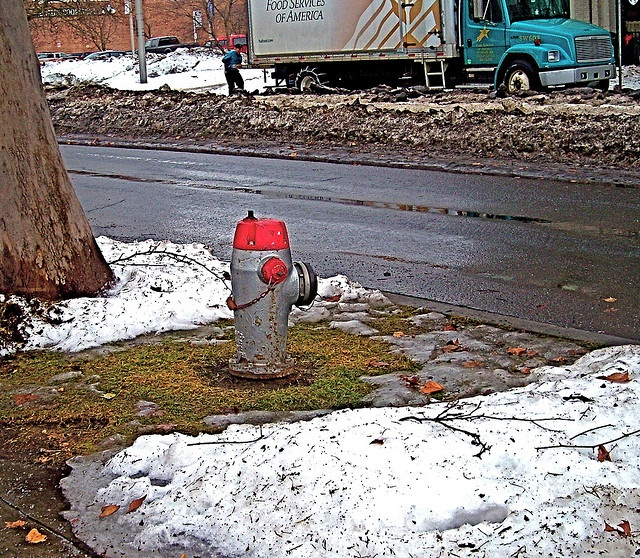Describe the objects in this image and their specific colors. I can see truck in black, darkgray, gray, and teal tones, fire hydrant in black, gray, darkgray, and maroon tones, people in black, blue, navy, and gray tones, truck in black, gray, darkgray, and lightgray tones, and car in black, white, gray, and darkgray tones in this image. 